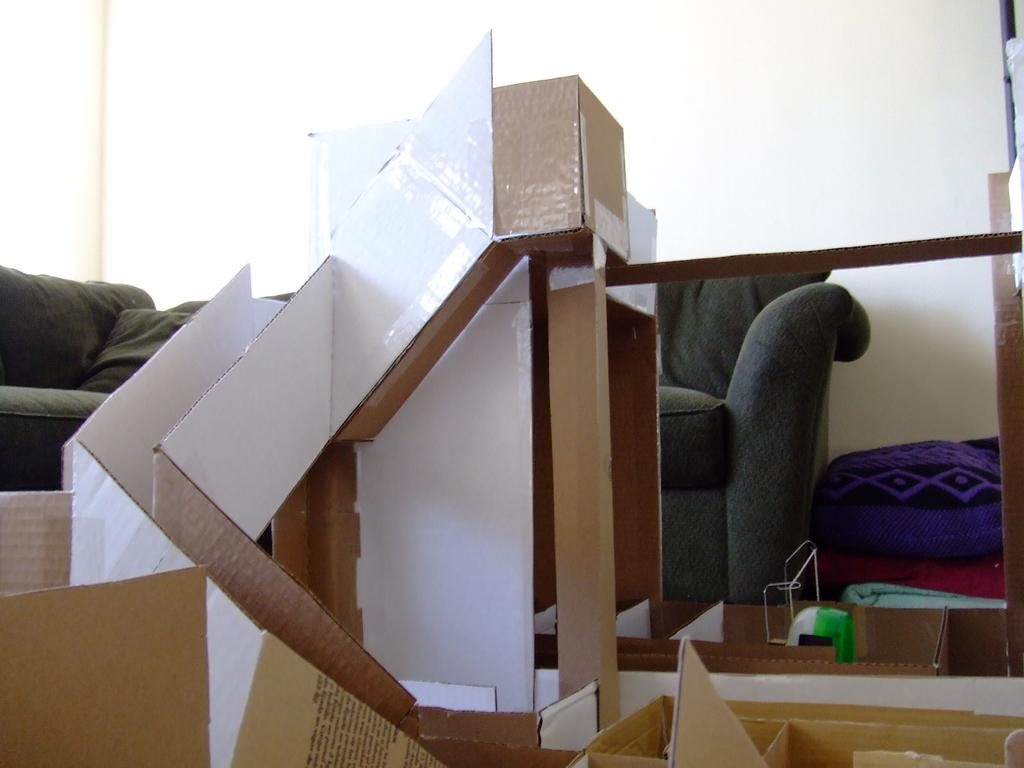What color is the wall in the background of the image? The wall in the background of the image is painted with white color. What type of furniture can be seen in the image? There are chairs in the image. What other objects are present in the image besides the chairs? Cardboards are present in the image. Can you describe the color of the pillow in the image? There is a pillow in blue color in the image. How many times does the spring appear in the image? There is no spring present in the image. What type of sorting is being done with the cardboards in the image? There is no sorting activity involving the cardboards in the image. 